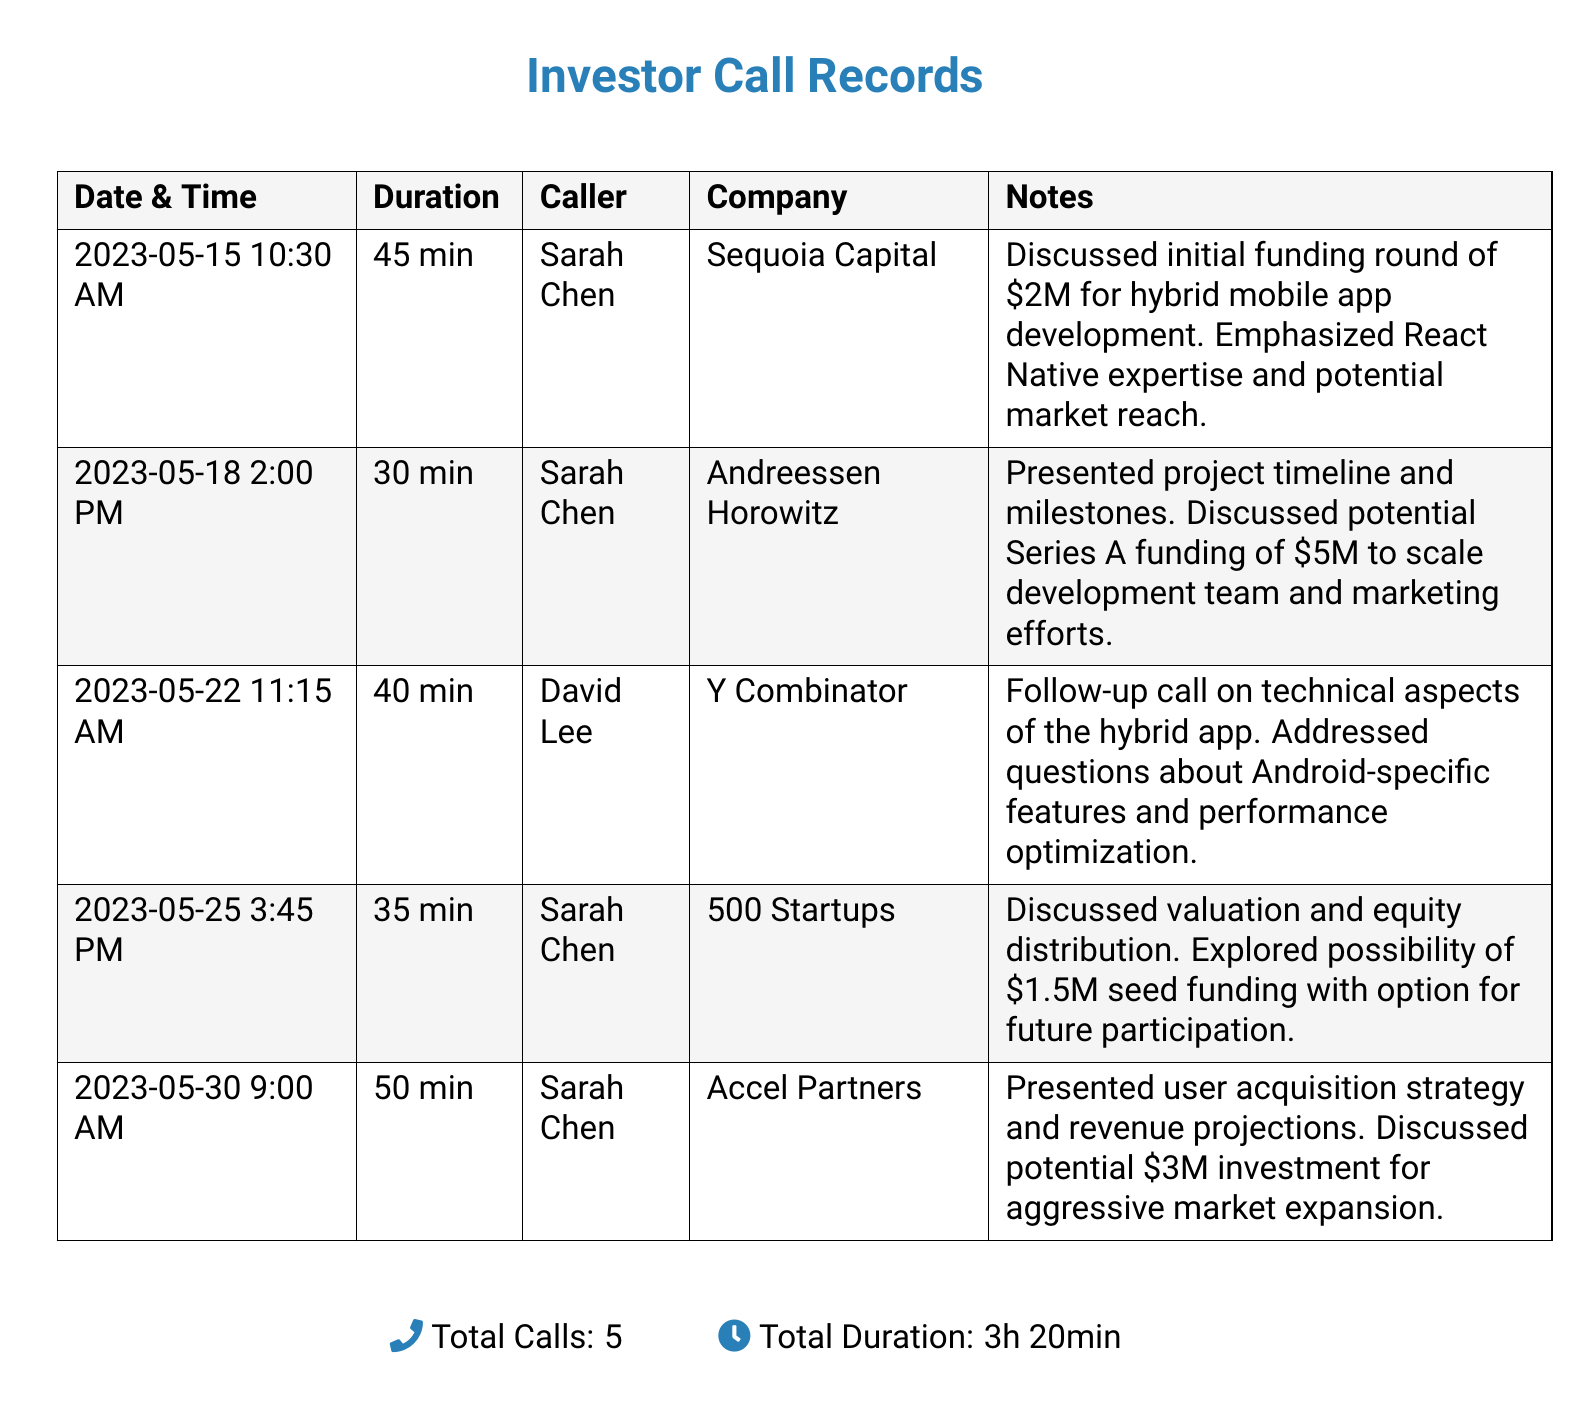What is the date of the first call? The first call took place on 2023-05-15.
Answer: 2023-05-15 Who was the caller for the call on May 22? The caller for the call on May 22 was David Lee.
Answer: David Lee What was the duration of the call with Accel Partners? The call with Accel Partners lasted for 50 minutes.
Answer: 50 min How much funding was discussed in the call with Sequoia Capital? The call with Sequoia Capital discussed an initial funding round of $2M.
Answer: $2M Which company was associated with the call that discussed Series A funding? The call discussing Series A funding was associated with Andreessen Horowitz.
Answer: Andreessen Horowitz What is the total duration of all calls? The total duration is the sum of all individual call durations, which is 3 hours and 20 minutes.
Answer: 3h 20min Who discussed valuation and equity distribution? Sarah Chen discussed valuation and equity distribution.
Answer: Sarah Chen What potential investment was discussed with 500 Startups? The potential investment discussed with 500 Startups was $1.5M seed funding.
Answer: $1.5M How many calls were conducted with Sarah Chen? There are three calls recorded with Sarah Chen.
Answer: 3 